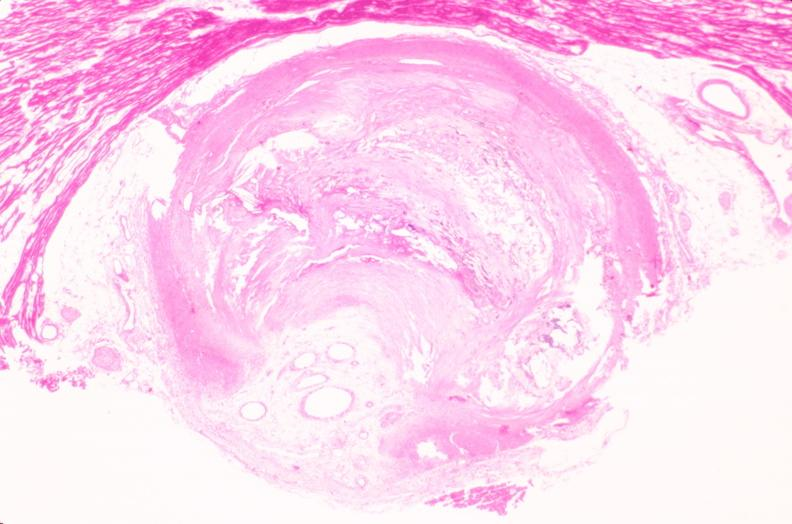what does this image show?
Answer the question using a single word or phrase. Coronary artery atherosclerosis 